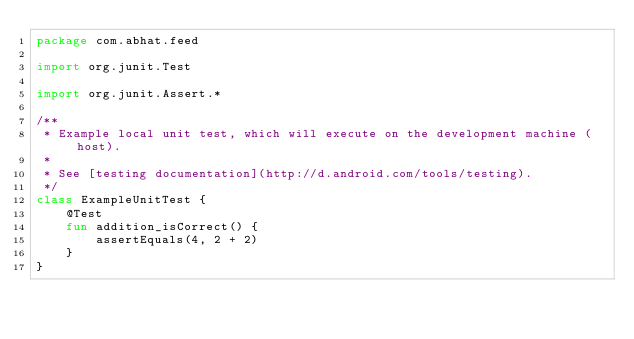<code> <loc_0><loc_0><loc_500><loc_500><_Kotlin_>package com.abhat.feed

import org.junit.Test

import org.junit.Assert.*

/**
 * Example local unit test, which will execute on the development machine (host).
 *
 * See [testing documentation](http://d.android.com/tools/testing).
 */
class ExampleUnitTest {
    @Test
    fun addition_isCorrect() {
        assertEquals(4, 2 + 2)
    }
}
</code> 